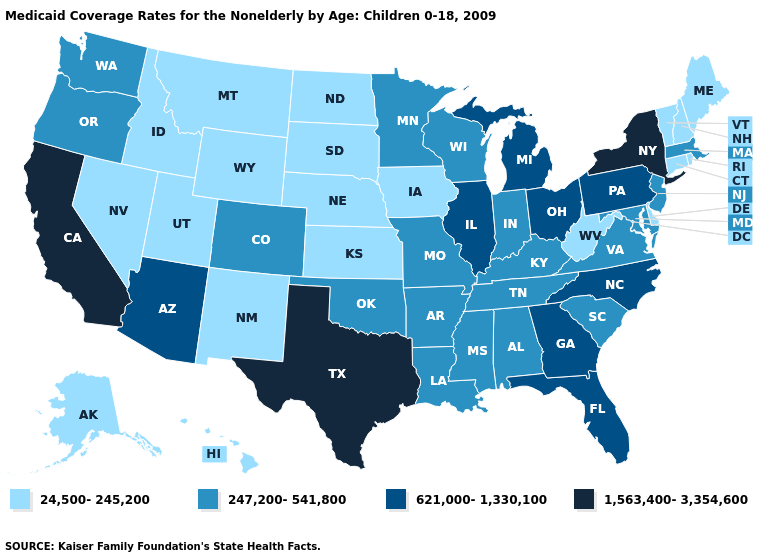What is the highest value in the West ?
Write a very short answer. 1,563,400-3,354,600. Name the states that have a value in the range 1,563,400-3,354,600?
Be succinct. California, New York, Texas. Which states have the lowest value in the South?
Be succinct. Delaware, West Virginia. Name the states that have a value in the range 247,200-541,800?
Short answer required. Alabama, Arkansas, Colorado, Indiana, Kentucky, Louisiana, Maryland, Massachusetts, Minnesota, Mississippi, Missouri, New Jersey, Oklahoma, Oregon, South Carolina, Tennessee, Virginia, Washington, Wisconsin. Among the states that border Wyoming , does Colorado have the lowest value?
Quick response, please. No. Among the states that border Maine , which have the lowest value?
Give a very brief answer. New Hampshire. What is the highest value in the South ?
Answer briefly. 1,563,400-3,354,600. Does New York have the lowest value in the USA?
Be succinct. No. What is the value of Hawaii?
Quick response, please. 24,500-245,200. Among the states that border Indiana , does Michigan have the lowest value?
Keep it brief. No. Name the states that have a value in the range 24,500-245,200?
Concise answer only. Alaska, Connecticut, Delaware, Hawaii, Idaho, Iowa, Kansas, Maine, Montana, Nebraska, Nevada, New Hampshire, New Mexico, North Dakota, Rhode Island, South Dakota, Utah, Vermont, West Virginia, Wyoming. How many symbols are there in the legend?
Answer briefly. 4. What is the highest value in states that border Nevada?
Concise answer only. 1,563,400-3,354,600. What is the value of California?
Answer briefly. 1,563,400-3,354,600. 